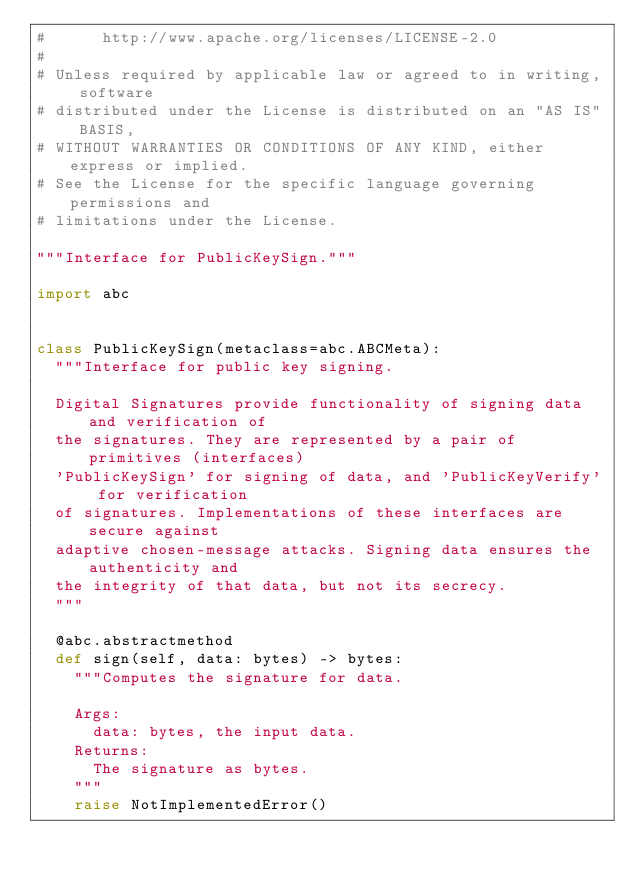Convert code to text. <code><loc_0><loc_0><loc_500><loc_500><_Python_>#      http://www.apache.org/licenses/LICENSE-2.0
#
# Unless required by applicable law or agreed to in writing, software
# distributed under the License is distributed on an "AS IS" BASIS,
# WITHOUT WARRANTIES OR CONDITIONS OF ANY KIND, either express or implied.
# See the License for the specific language governing permissions and
# limitations under the License.

"""Interface for PublicKeySign."""

import abc


class PublicKeySign(metaclass=abc.ABCMeta):
  """Interface for public key signing.

  Digital Signatures provide functionality of signing data and verification of
  the signatures. They are represented by a pair of primitives (interfaces)
  'PublicKeySign' for signing of data, and 'PublicKeyVerify' for verification
  of signatures. Implementations of these interfaces are secure against
  adaptive chosen-message attacks. Signing data ensures the authenticity and
  the integrity of that data, but not its secrecy.
  """

  @abc.abstractmethod
  def sign(self, data: bytes) -> bytes:
    """Computes the signature for data.

    Args:
      data: bytes, the input data.
    Returns:
      The signature as bytes.
    """
    raise NotImplementedError()
</code> 